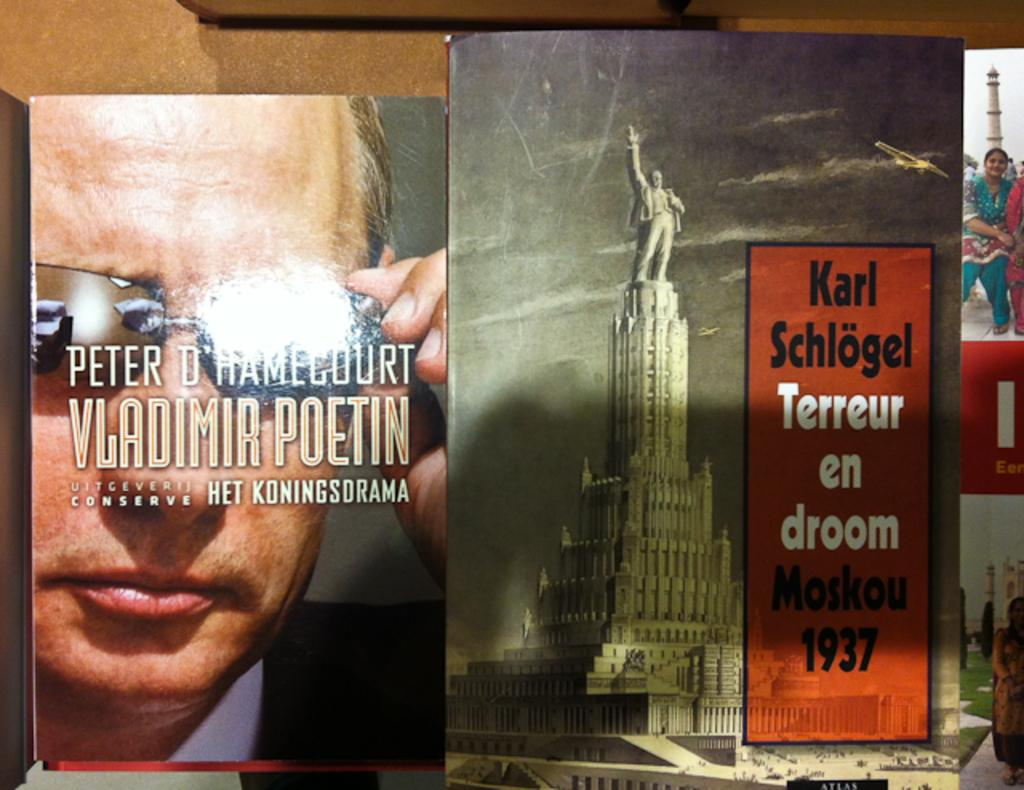What type of decoration is featured on the wallpapers in the image? The wallpapers in the image have pictures of statues, women, and men. What else can be seen on the wallpapers besides the images? There is text on the wallpapers. How many legs can be seen on the representative in the image? There is no representative present in the image, so it is not possible to determine the number of legs. 